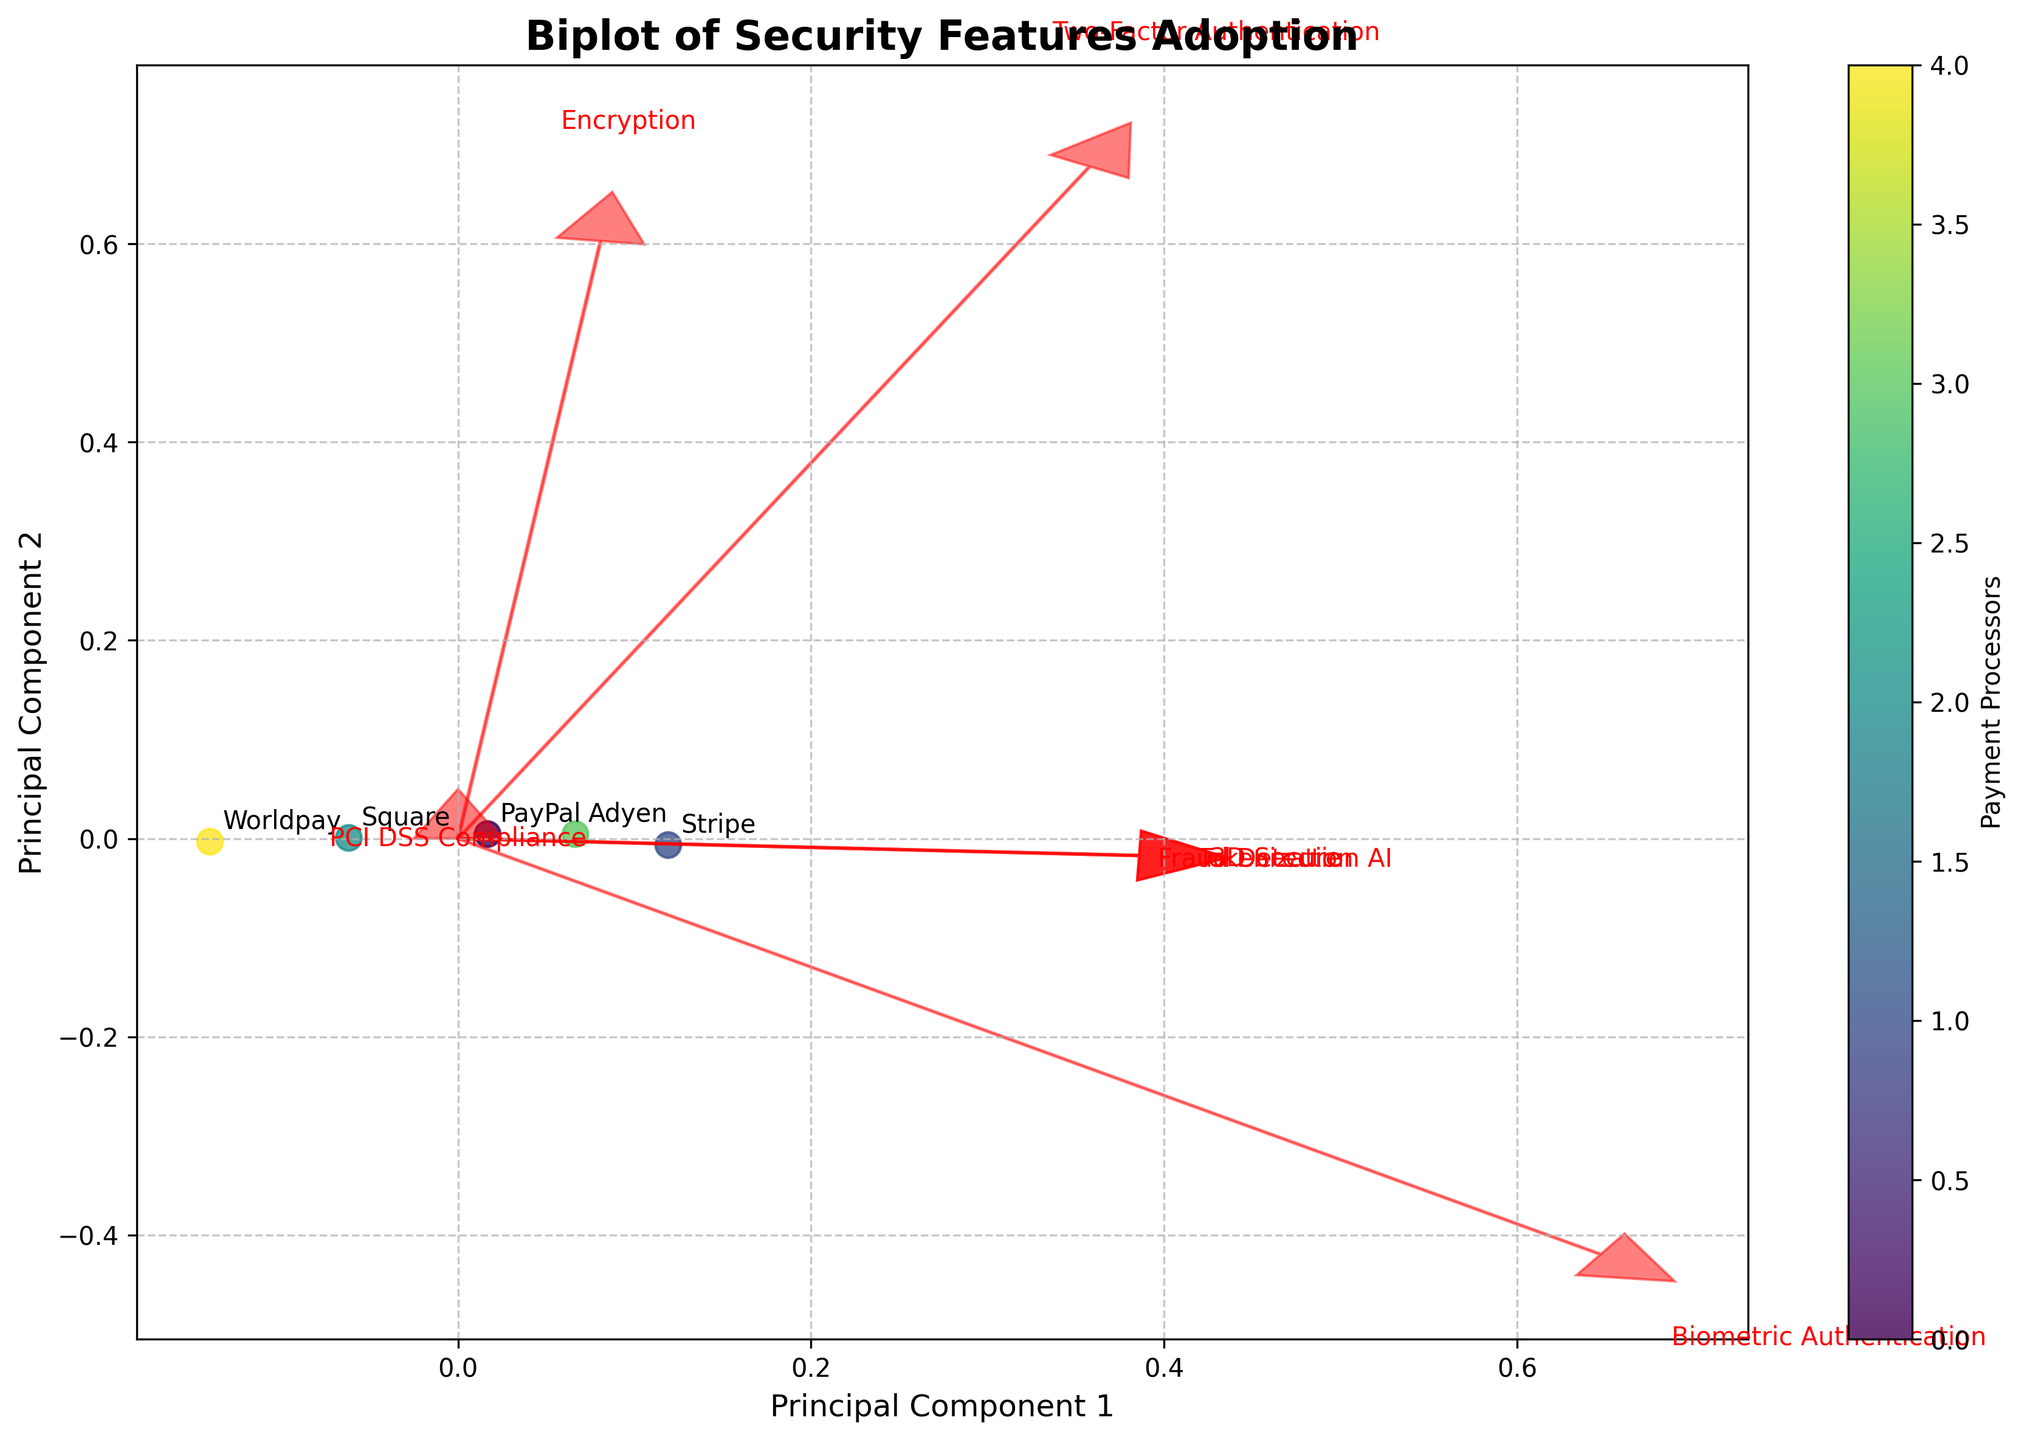How many payment processors are compared in this figure? There are five data points plotted in different positions. Each point represents one payment processor, and the legend or color bar can further confirm this.
Answer: Five What are the two principal components in the figure's axes? The x-axis is labeled 'Principal Component 1' and the y-axis is labeled 'Principal Component 2'. These labels indicate the two principal components identified by the PCA.
Answer: Principal Component 1 and Principal Component 2 Which payment processor is closest to the origin of the biplot? By observing the positions of each payment processor relative to the origin (0, 0), Stripe is the closest one. This can be identified visually based on the distance from each point to the intersection of the axes.
Answer: Stripe Which security feature has the most alignment with Principal Component 1? By examining the direction of the feature vectors (red arrows) relative to the x-axis (Principal Component 1), Encryption appears most aligned since the corresponding arrow stretches furthest along this axis.
Answer: Encryption How does Two-Factor Authentication compare between PayPal and Worldpay? PayPal and Worldpay are represented by separate points, and you can observe their projection onto the vector representing Two-Factor Authentication (highlighted in red). The lengths of these projections show that PayPal has higher adoption (0.95) compared to Worldpay (0.89).
Answer: PayPal has higher adoption Which security feature influences Principal Component 2 the least? To determine this, observe which feature vector (red arrow) is closest to being horizontal, indicating minimal influence on the y-axis (Principal Component 2). Biometric Authentication influences Principal Component 2 the least.
Answer: Biometric Authentication Considering both Principal Components, which payment processor shows the greatest overall security feature adoption? The biplot shows the collective positioning of processors relative to vectors representing different security features. By combining distances from various features, Stripe is positioned to show the highest aggregate alignment with most security features.
Answer: Stripe Which processors have a similar adoption rate for the Encryption security feature? By looking at the projection along the vector representing Encryption, we can see processors close to each other along this dimension. PayPal, Stripe, Adyen, and Square all show similar levels of adoption near the maximum value, around 0.98-0.99.
Answer: PayPal, Stripe, Adyen, and Square What security feature demonstrates a notable variance in adoption across all payment processors? By evaluating the spread of projections along the vector for each security feature, Biometric Authentication shows notable variance—some processors score around 0.65 while others are significantly lower at 0.55.
Answer: Biometric Authentication 